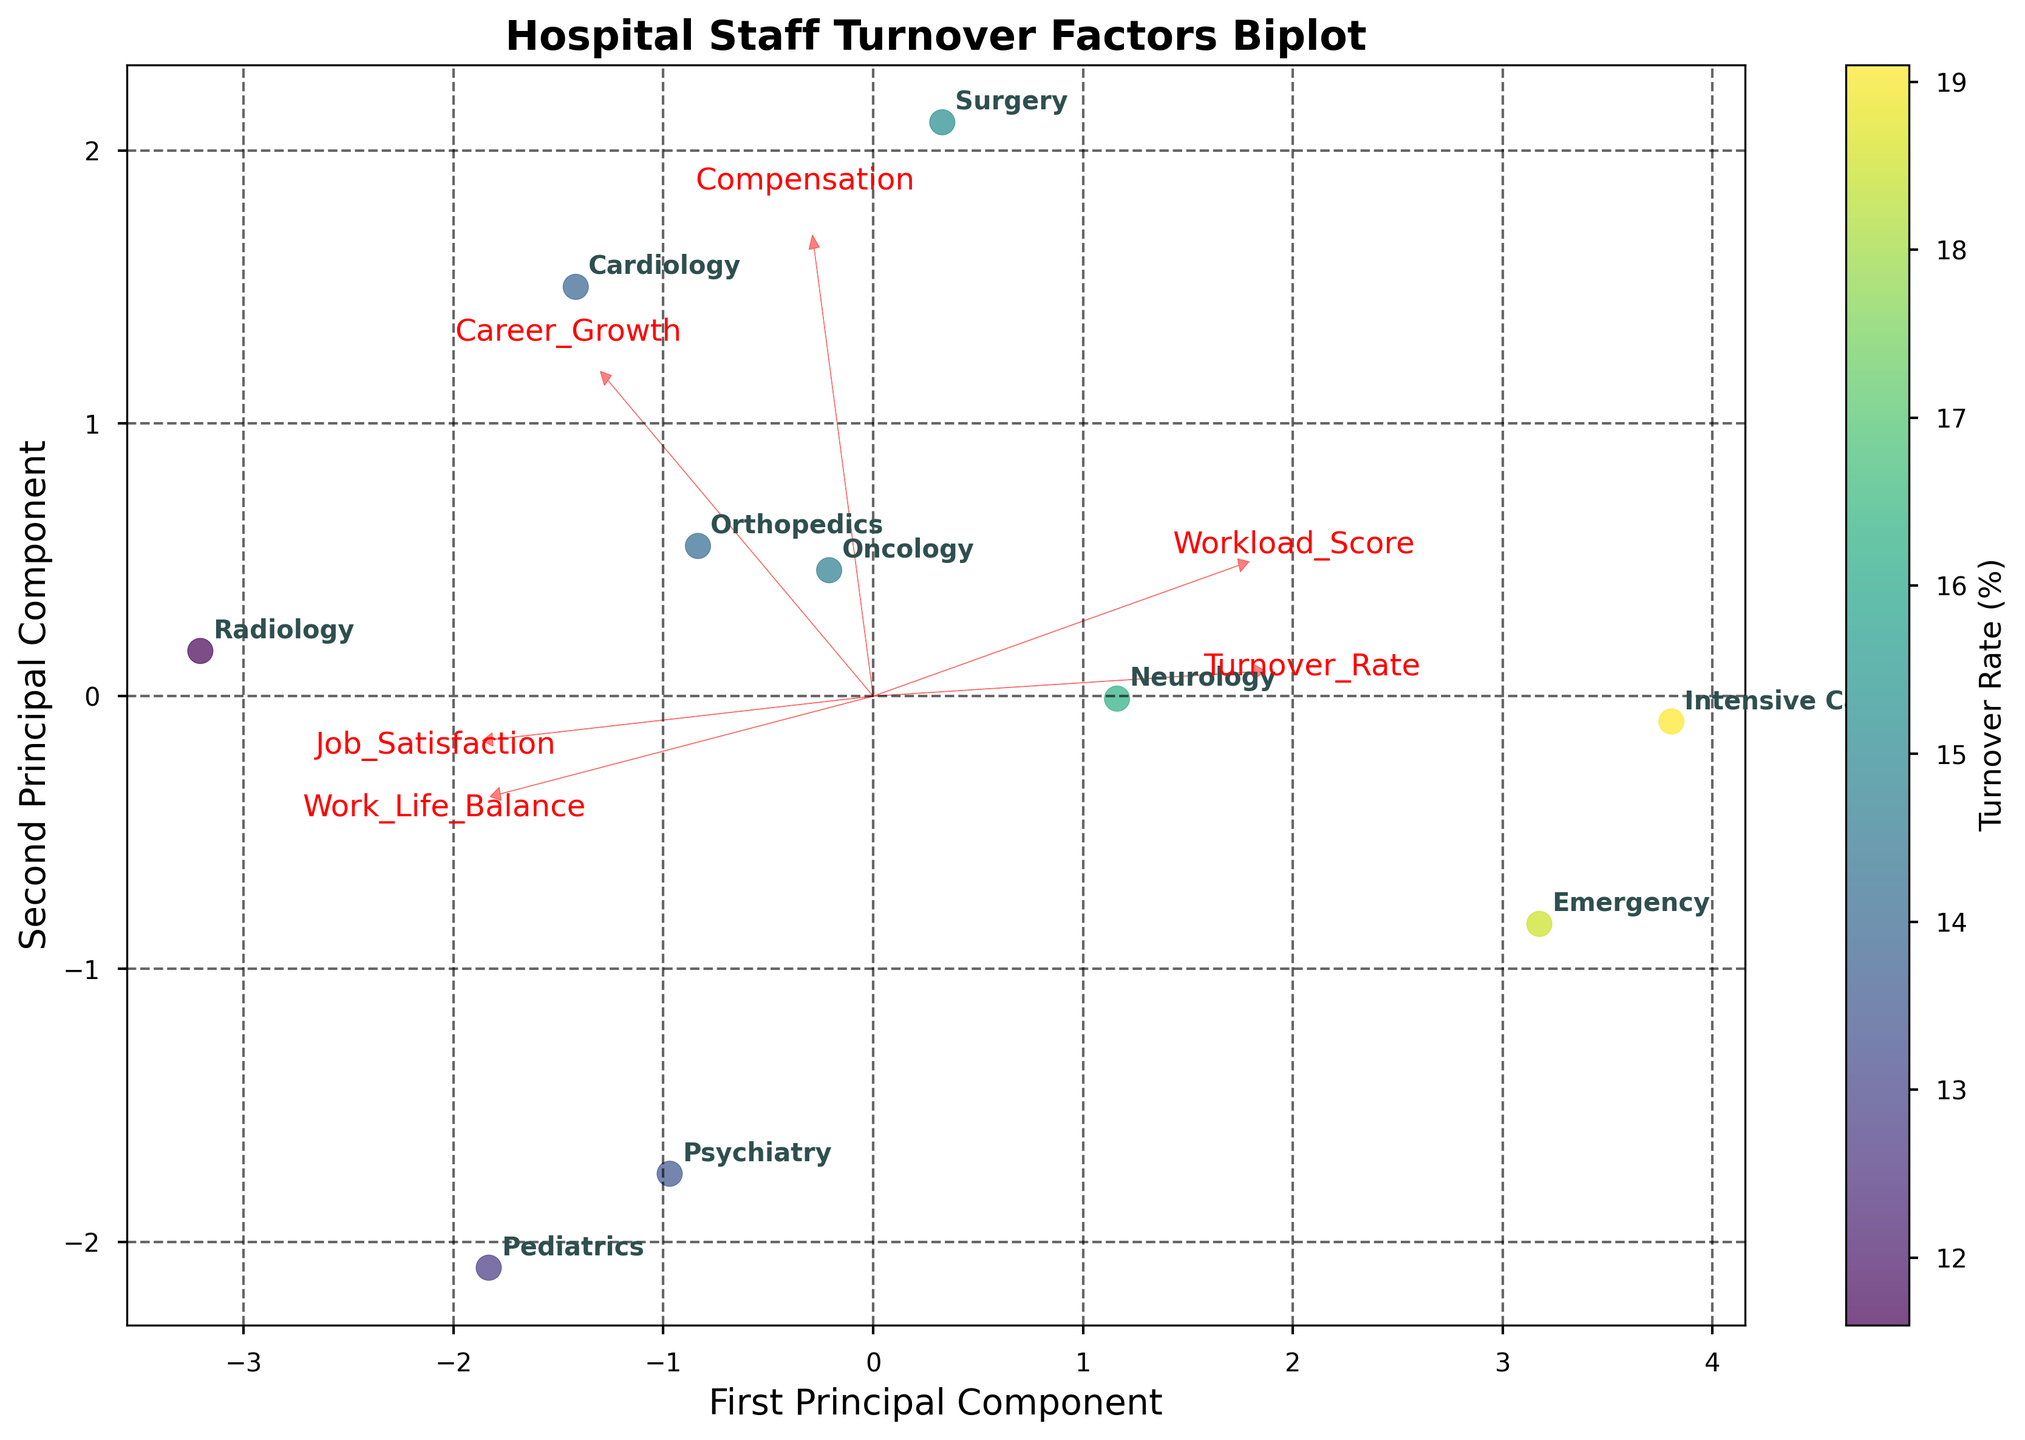What is the title of the figure? The title of the figure is displayed at the top and provides information on what the figure represents. It reads "Hospital Staff Turnover Factors Biplot".
Answer: Hospital Staff Turnover Factors Biplot How many departments are represented in the biplot? Count the number of unique department labels annotated on the biplot. There are 10 departments represented.
Answer: 10 Which department has the highest turnover rate according to the colorbar? The colorbar indicates the turnover rate through color intensity. The Emergency department, which is colored the darkest shade of the 'viridis' colormap, has the highest turnover rate.
Answer: Emergency Which direction does the arrow for 'Workload_Score' point, and what does it indicate? The arrow for 'Workload_Score' points to the top-right direction, indicating that higher workload scores are associated with higher values on the first and second principal components.
Answer: Top-right Between Surgery and Pediatrics, which department scores higher on job satisfaction? By locating the positions of the Surgery and Pediatrics departments and observing the direction of the 'Job_Satisfaction' vector, it can be seen that Pediatrics is further along the 'Job_Satisfaction' vector.
Answer: Pediatrics How does the 'Turnover_Rate' relate to 'Job_Satisfaction' given their directional vectors on the plot? 'Turnover_Rate' and 'Job_Satisfaction' vectors point in roughly opposite directions, suggesting an inverse relationship where higher job satisfaction correlates with lower turnover rates.
Answer: Inversely related Which department is closest to the origin (0,0) point in the biplot? The department with the coordinates closest to (0,0) on both the first and second principal components is Oncology.
Answer: Oncology If you consider only 'Career_Growth' and 'Compensation,' which department stands out the most? By examining the directions and lengths of the 'Career_Growth' and 'Compensation' vectors, Radiology is most positively positioned in the direction of these vectors, indicating higher career growth and compensation.
Answer: Radiology Is there a positive or negative correlation between 'Work_Life_Balance' and 'Turnover_Rate'? The vectors for 'Work_Life_Balance' and 'Turnover_Rate' point in roughly opposite directions, indicating a negative correlation between these factors.
Answer: Negative Which department appears to be most balanced among all workplace factors (as positioned near zero for all vectors)? The department nearest the origin, implying a balanced position across all factors without extremes in any direction, is Oncology.
Answer: Oncology 